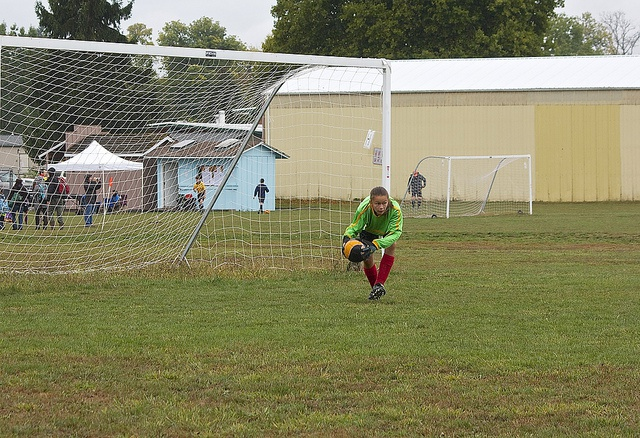Describe the objects in this image and their specific colors. I can see people in lightgray, black, maroon, olive, and darkgreen tones, people in lightgray, black, darkgray, gray, and olive tones, people in lightgray, black, gray, and darkgray tones, people in lightgray, black, gray, and darkgray tones, and people in lightgray, black, gray, darkgray, and navy tones in this image. 